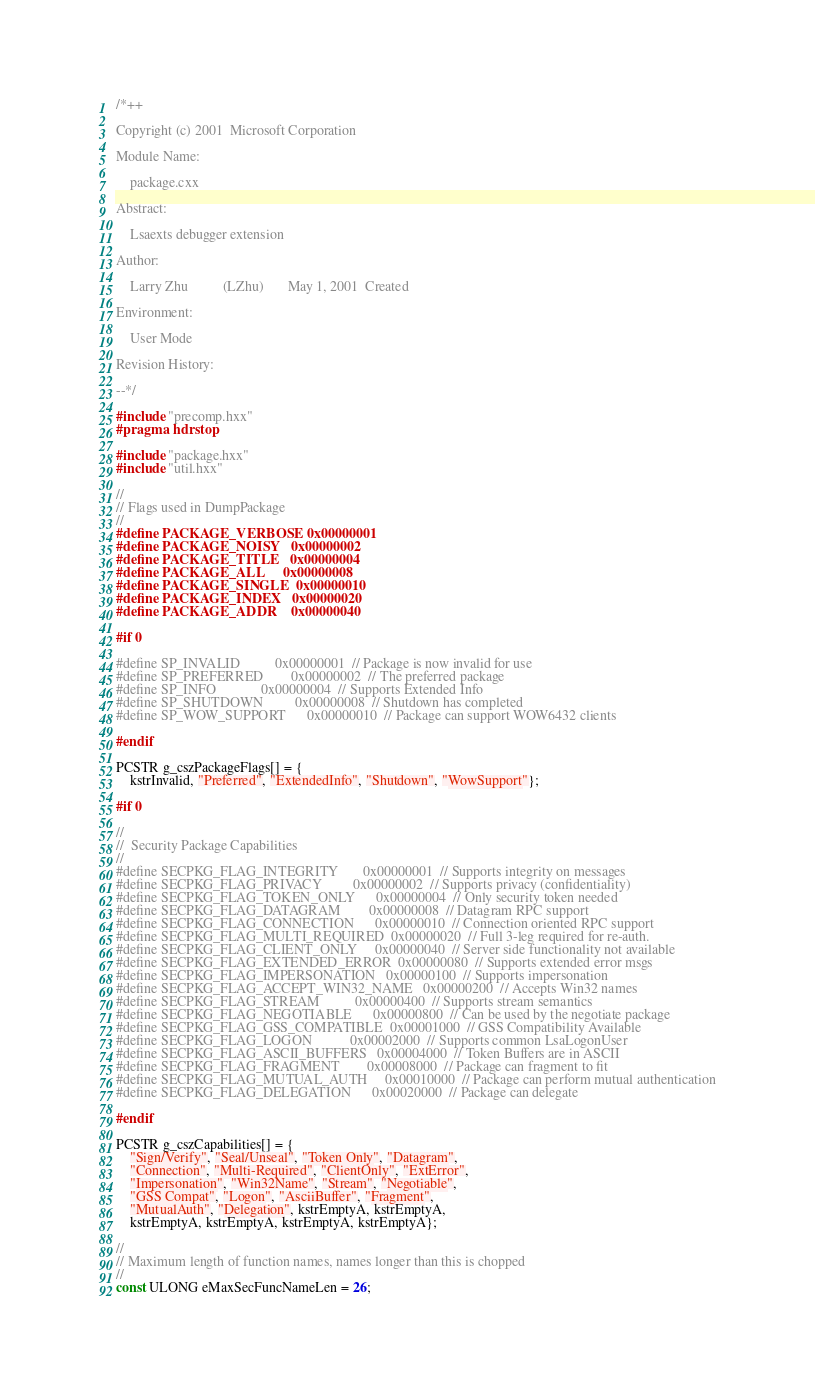<code> <loc_0><loc_0><loc_500><loc_500><_C++_>/*++

Copyright (c) 2001  Microsoft Corporation

Module Name:

    package.cxx

Abstract:

    Lsaexts debugger extension

Author:

    Larry Zhu          (LZhu)       May 1, 2001  Created

Environment:

    User Mode

Revision History:

--*/

#include "precomp.hxx"
#pragma hdrstop

#include "package.hxx"
#include "util.hxx"

//
// Flags used in DumpPackage
//
#define PACKAGE_VERBOSE 0x00000001
#define PACKAGE_NOISY   0x00000002
#define PACKAGE_TITLE   0x00000004
#define PACKAGE_ALL     0x00000008
#define PACKAGE_SINGLE  0x00000010
#define PACKAGE_INDEX   0x00000020
#define PACKAGE_ADDR    0x00000040

#if 0

#define SP_INVALID          0x00000001  // Package is now invalid for use
#define SP_PREFERRED        0x00000002  // The preferred package
#define SP_INFO             0x00000004  // Supports Extended Info
#define SP_SHUTDOWN         0x00000008  // Shutdown has completed
#define SP_WOW_SUPPORT      0x00000010  // Package can support WOW6432 clients

#endif

PCSTR g_cszPackageFlags[] = {
    kstrInvalid, "Preferred", "ExtendedInfo", "Shutdown", "WowSupport"};

#if 0

//
//  Security Package Capabilities
//
#define SECPKG_FLAG_INTEGRITY       0x00000001  // Supports integrity on messages
#define SECPKG_FLAG_PRIVACY         0x00000002  // Supports privacy (confidentiality)
#define SECPKG_FLAG_TOKEN_ONLY      0x00000004  // Only security token needed
#define SECPKG_FLAG_DATAGRAM        0x00000008  // Datagram RPC support
#define SECPKG_FLAG_CONNECTION      0x00000010  // Connection oriented RPC support
#define SECPKG_FLAG_MULTI_REQUIRED  0x00000020  // Full 3-leg required for re-auth.
#define SECPKG_FLAG_CLIENT_ONLY     0x00000040  // Server side functionality not available
#define SECPKG_FLAG_EXTENDED_ERROR  0x00000080  // Supports extended error msgs
#define SECPKG_FLAG_IMPERSONATION   0x00000100  // Supports impersonation
#define SECPKG_FLAG_ACCEPT_WIN32_NAME   0x00000200  // Accepts Win32 names
#define SECPKG_FLAG_STREAM          0x00000400  // Supports stream semantics
#define SECPKG_FLAG_NEGOTIABLE      0x00000800  // Can be used by the negotiate package
#define SECPKG_FLAG_GSS_COMPATIBLE  0x00001000  // GSS Compatibility Available
#define SECPKG_FLAG_LOGON           0x00002000  // Supports common LsaLogonUser
#define SECPKG_FLAG_ASCII_BUFFERS   0x00004000  // Token Buffers are in ASCII
#define SECPKG_FLAG_FRAGMENT        0x00008000  // Package can fragment to fit
#define SECPKG_FLAG_MUTUAL_AUTH     0x00010000  // Package can perform mutual authentication
#define SECPKG_FLAG_DELEGATION      0x00020000  // Package can delegate

#endif

PCSTR g_cszCapabilities[] = {
    "Sign/Verify", "Seal/Unseal", "Token Only", "Datagram",
    "Connection", "Multi-Required", "ClientOnly", "ExtError",
    "Impersonation", "Win32Name", "Stream", "Negotiable",
    "GSS Compat", "Logon", "AsciiBuffer", "Fragment",
    "MutualAuth", "Delegation", kstrEmptyA, kstrEmptyA,
    kstrEmptyA, kstrEmptyA, kstrEmptyA, kstrEmptyA};

//
// Maximum length of function names, names longer than this is chopped
//
const ULONG eMaxSecFuncNameLen = 26;
</code> 